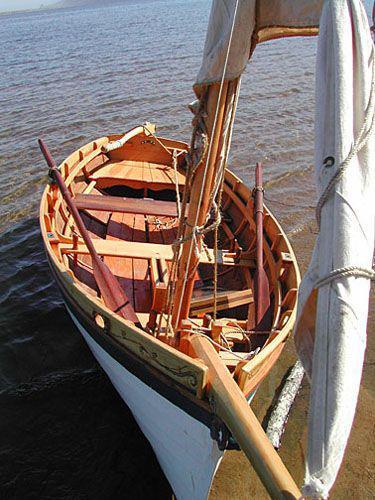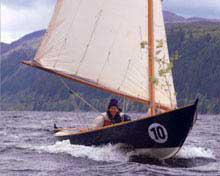The first image is the image on the left, the second image is the image on the right. For the images shown, is this caption "One person is in a sailboat in the image on the left." true? Answer yes or no. No. 